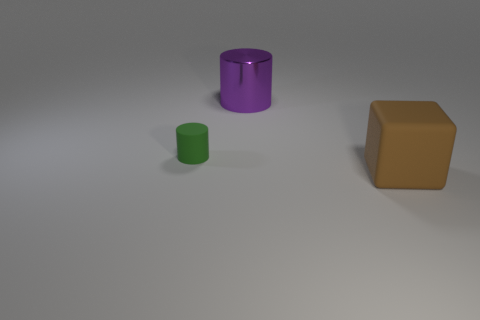If I were to add a fourth object, what would complement the scene? Introducing a fourth object such as a sphere would add variety and complement the scene. Choosing a color like blue or orange would introduce a new element while maintaining a harmonious palette. Placing it in a way that maintains balance in the composition would further enhance the aesthetic appeal. 